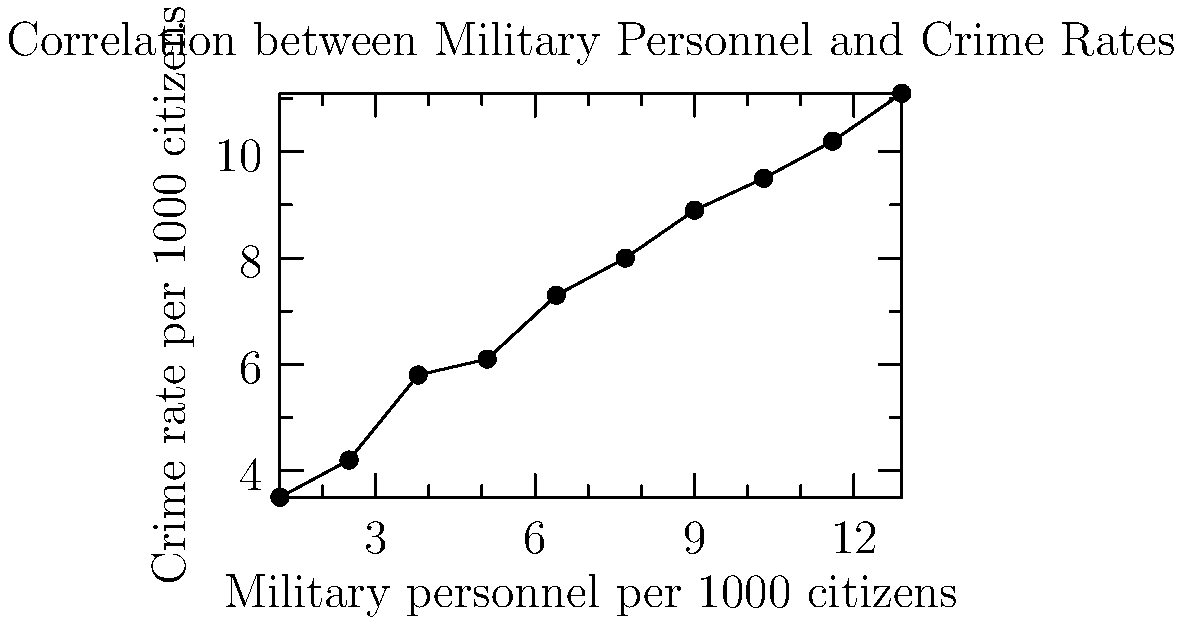Based on the scatter plot showing the relationship between military personnel per 1000 citizens and crime rates per 1000 citizens, calculate the Pearson correlation coefficient (r) to two decimal places. What does this value suggest about the relationship between militarization and crime rates? To calculate the Pearson correlation coefficient (r), we'll follow these steps:

1. Calculate the means of x and y:
   $\bar{x} = 7.05$, $\bar{y} = 7.46$

2. Calculate the deviations from the mean for x and y:
   $x_i - \bar{x}$ and $y_i - \bar{y}$

3. Calculate the products of the deviations:
   $(x_i - \bar{x})(y_i - \bar{y})$

4. Sum the products of deviations:
   $\sum (x_i - \bar{x})(y_i - \bar{y}) = 118.945$

5. Calculate the sum of squared deviations for x and y:
   $\sum (x_i - \bar{x})^2 = 151.525$
   $\sum (y_i - \bar{y})^2 = 93.949$

6. Apply the formula for Pearson's r:
   $r = \frac{\sum (x_i - \bar{x})(y_i - \bar{y})}{\sqrt{\sum (x_i - \bar{x})^2 \sum (y_i - \bar{y})^2}}$

   $r = \frac{118.945}{\sqrt{151.525 \times 93.949}} = 0.9897$

7. Round to two decimal places: $r = 0.99$

This value suggests a very strong positive correlation between militarization and crime rates. As the number of military personnel per 1000 citizens increases, there is a strong tendency for the crime rate per 1000 citizens to increase as well.
Answer: $r = 0.99$; very strong positive correlation 